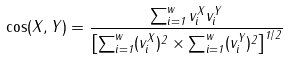Convert formula to latex. <formula><loc_0><loc_0><loc_500><loc_500>\cos ( X , Y ) = \frac { \sum _ { i = 1 } ^ { w } v ^ { X } _ { i } v ^ { Y } _ { i } } { \left [ \sum _ { i = 1 } ^ { w } ( v ^ { X } _ { i } ) ^ { 2 } \times \sum _ { i = 1 } ^ { w } ( v ^ { Y } _ { i } ) ^ { 2 } \right ] ^ { 1 / 2 } }</formula> 